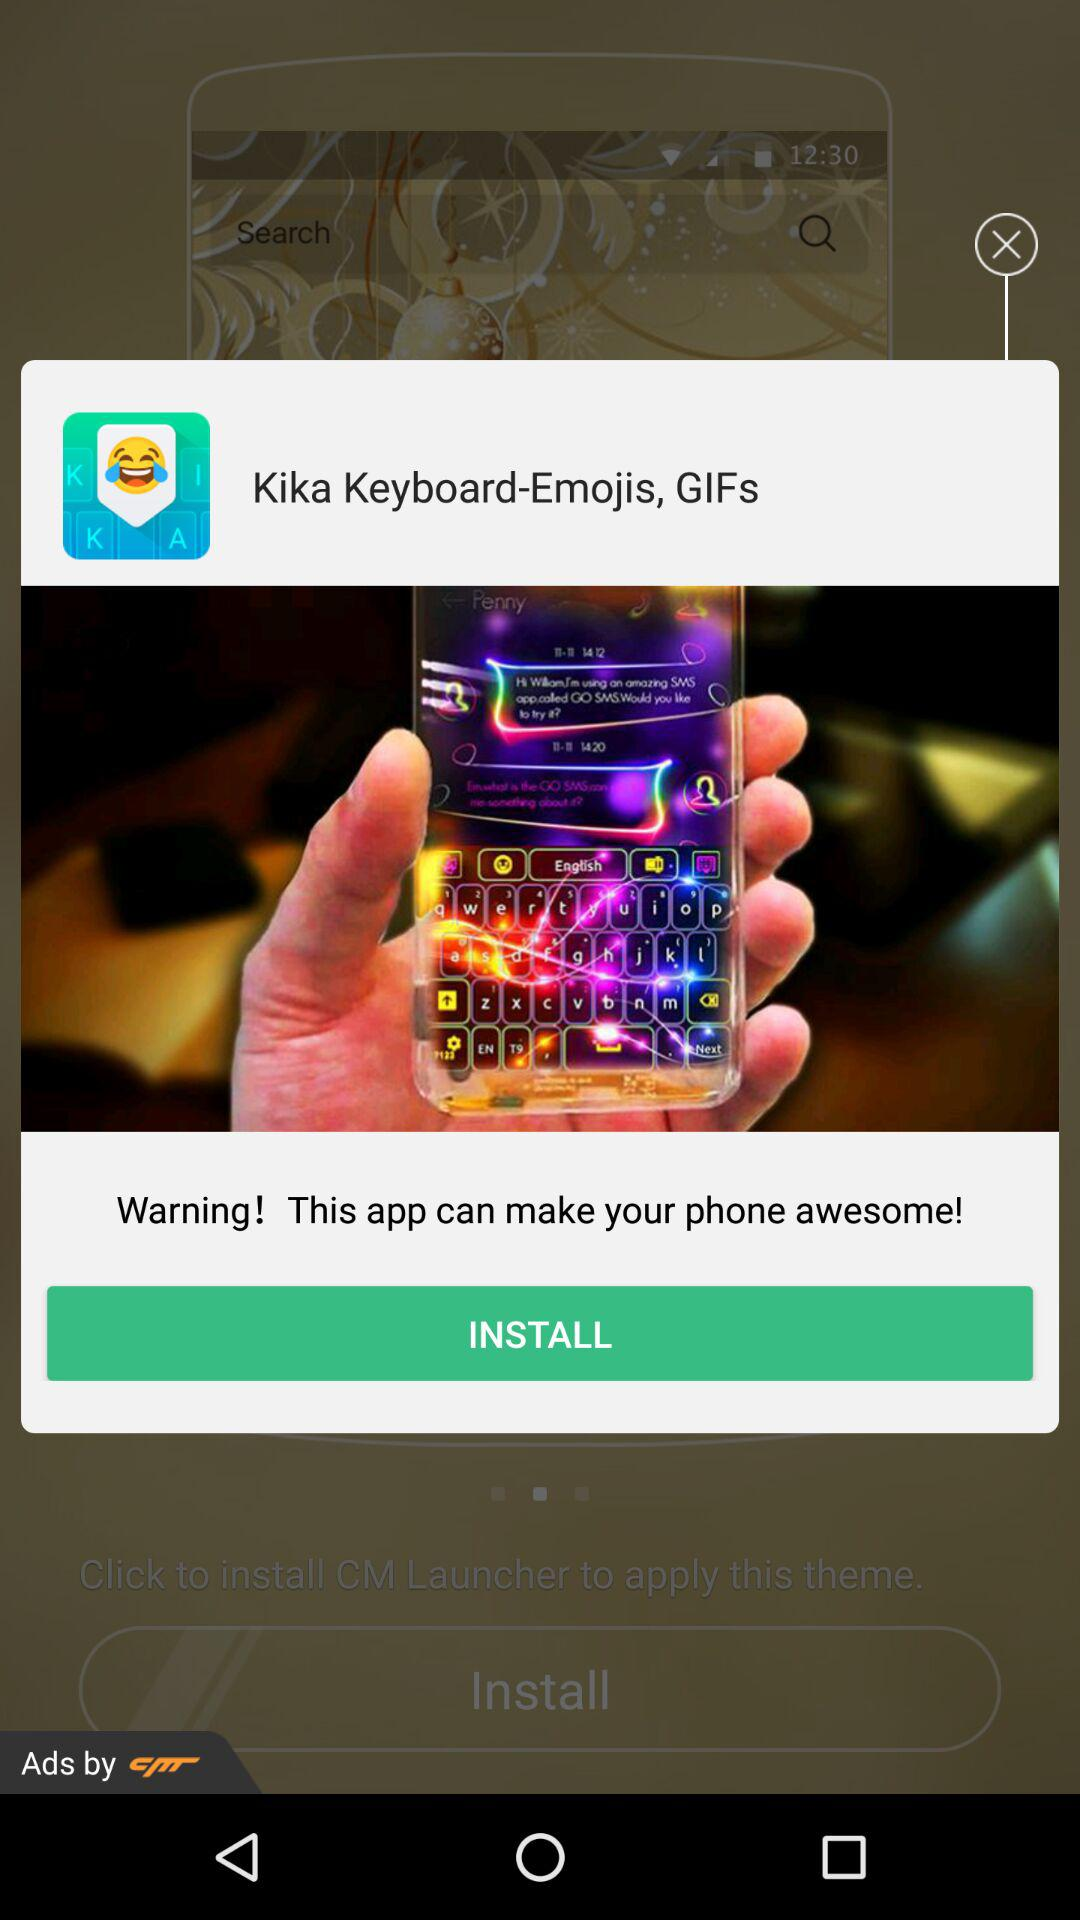What is the name of the application? The name of the application is "Kika Keyboard-Emojis, GIFs". 